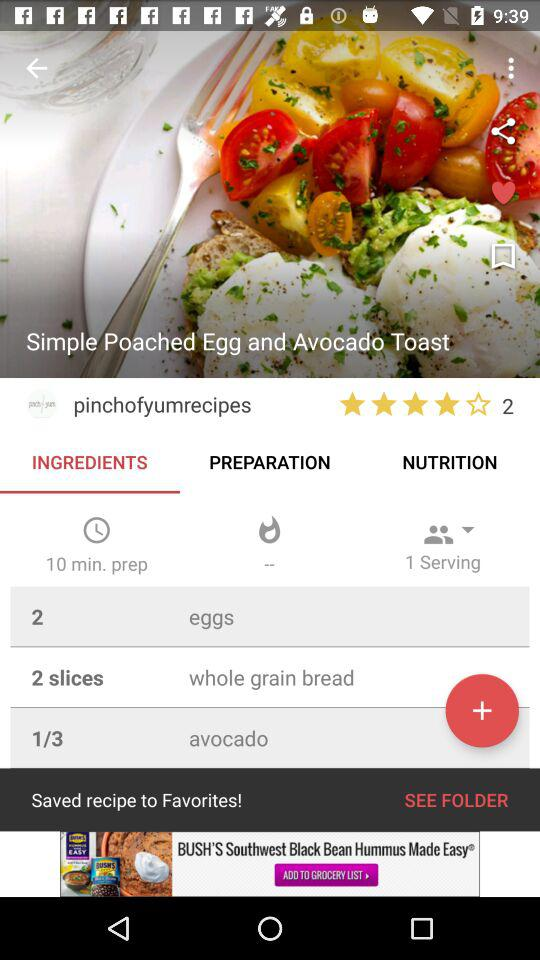What is the preparation time of the dish? The preparation time of the dish is 10 minutes. 